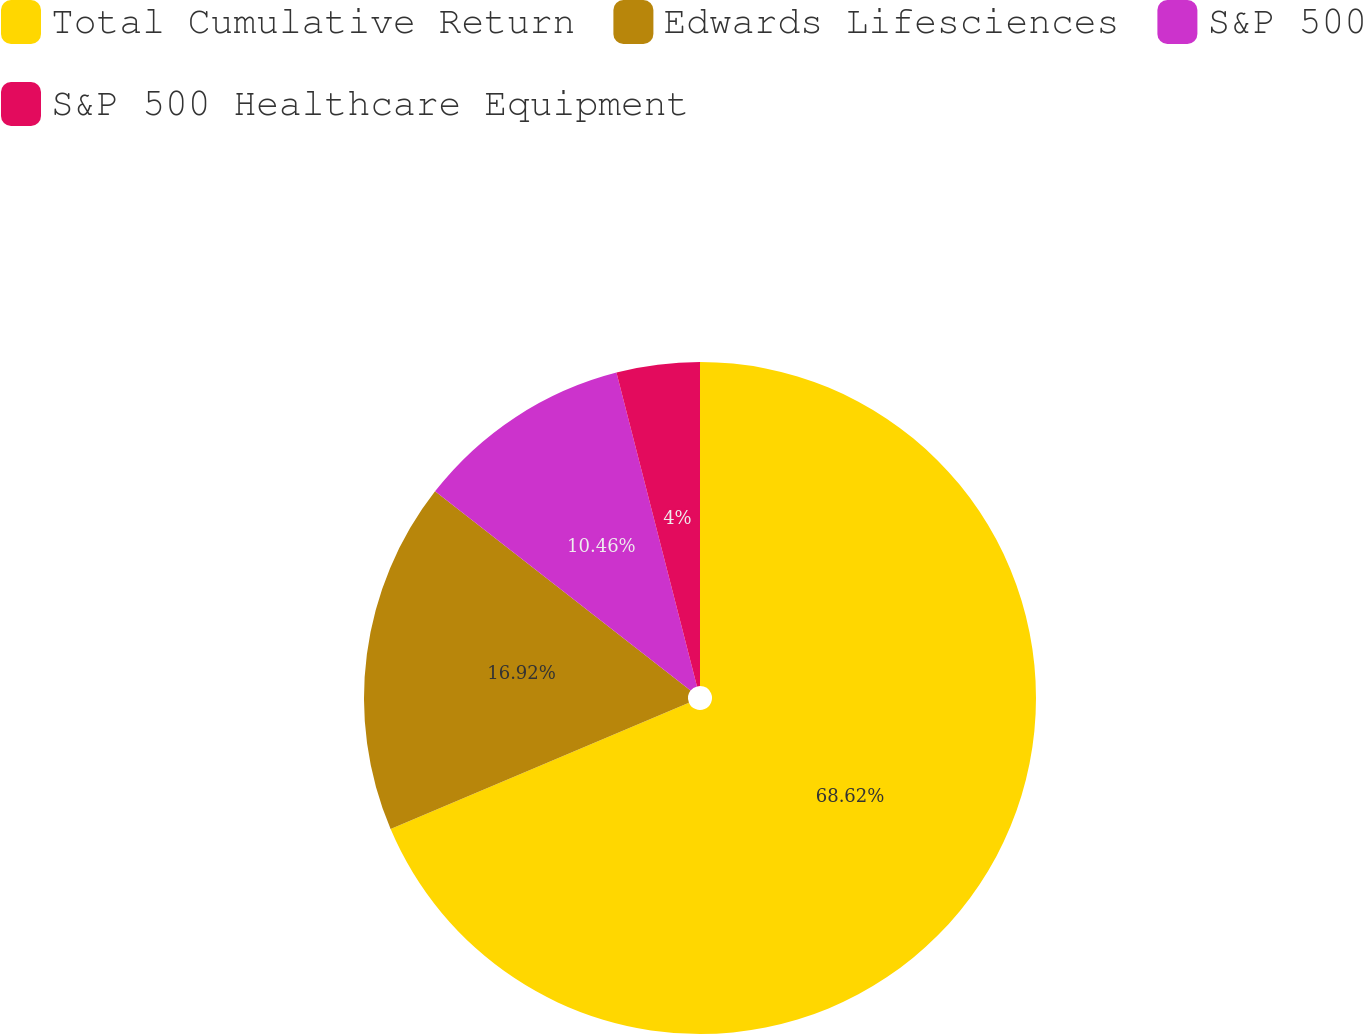<chart> <loc_0><loc_0><loc_500><loc_500><pie_chart><fcel>Total Cumulative Return<fcel>Edwards Lifesciences<fcel>S&P 500<fcel>S&P 500 Healthcare Equipment<nl><fcel>68.63%<fcel>16.92%<fcel>10.46%<fcel>4.0%<nl></chart> 